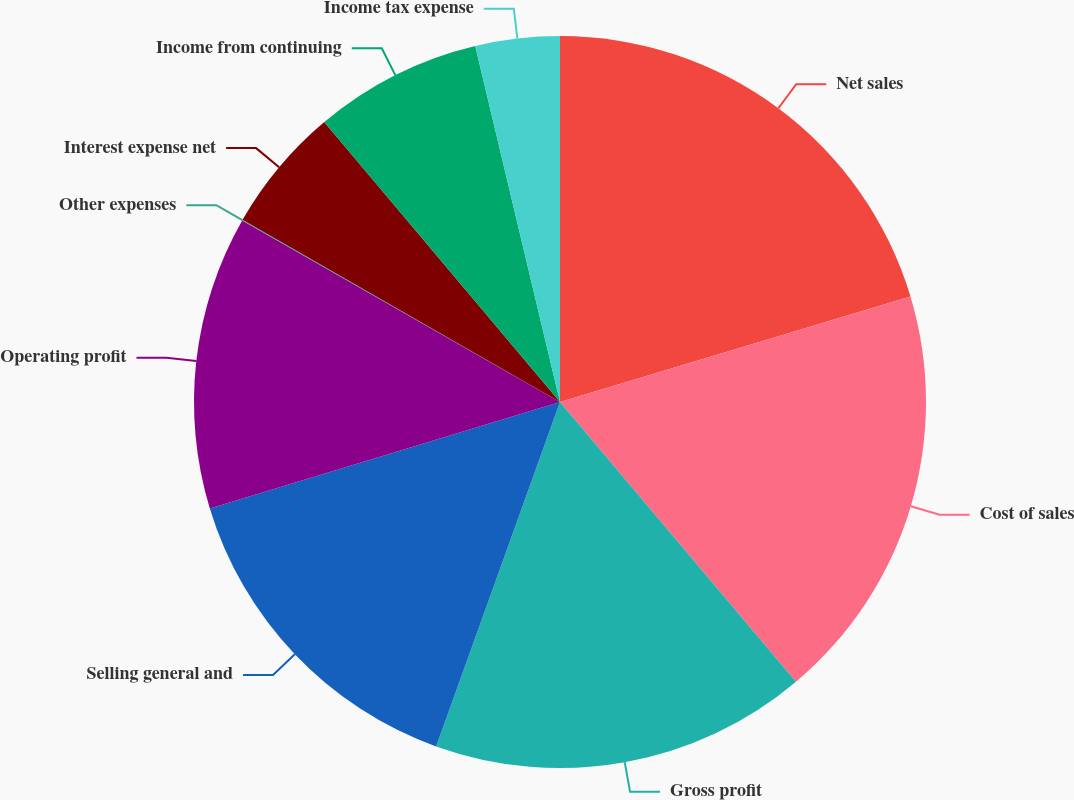Convert chart to OTSL. <chart><loc_0><loc_0><loc_500><loc_500><pie_chart><fcel>Net sales<fcel>Cost of sales<fcel>Gross profit<fcel>Selling general and<fcel>Operating profit<fcel>Other expenses<fcel>Interest expense net<fcel>Income from continuing<fcel>Income tax expense<nl><fcel>20.35%<fcel>18.5%<fcel>16.65%<fcel>14.81%<fcel>12.96%<fcel>0.03%<fcel>5.57%<fcel>7.42%<fcel>3.72%<nl></chart> 